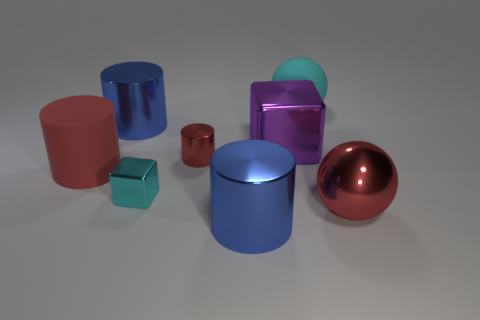The red matte object has what size?
Make the answer very short. Large. What number of things are gray rubber blocks or big cyan balls?
Your answer should be compact. 1. What color is the big ball that is made of the same material as the big cube?
Make the answer very short. Red. There is a large blue thing that is behind the purple block; is it the same shape as the purple metal object?
Your response must be concise. No. How many things are either matte objects that are right of the tiny red metal cylinder or red objects behind the large red metal sphere?
Your response must be concise. 3. The other object that is the same shape as the purple shiny thing is what color?
Provide a short and direct response. Cyan. Are there any other things that have the same shape as the tiny cyan metallic object?
Your answer should be very brief. Yes. There is a purple metal thing; is it the same shape as the blue metal object in front of the large red ball?
Keep it short and to the point. No. What material is the large block?
Your answer should be very brief. Metal. What is the size of the cyan metal thing that is the same shape as the purple thing?
Provide a short and direct response. Small. 